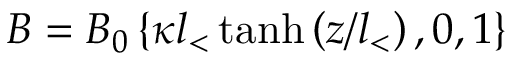<formula> <loc_0><loc_0><loc_500><loc_500>B = B _ { 0 } \left \{ \kappa l _ { < } \, t a n h \left ( z / l _ { < } \right ) , 0 , 1 \right \}</formula> 